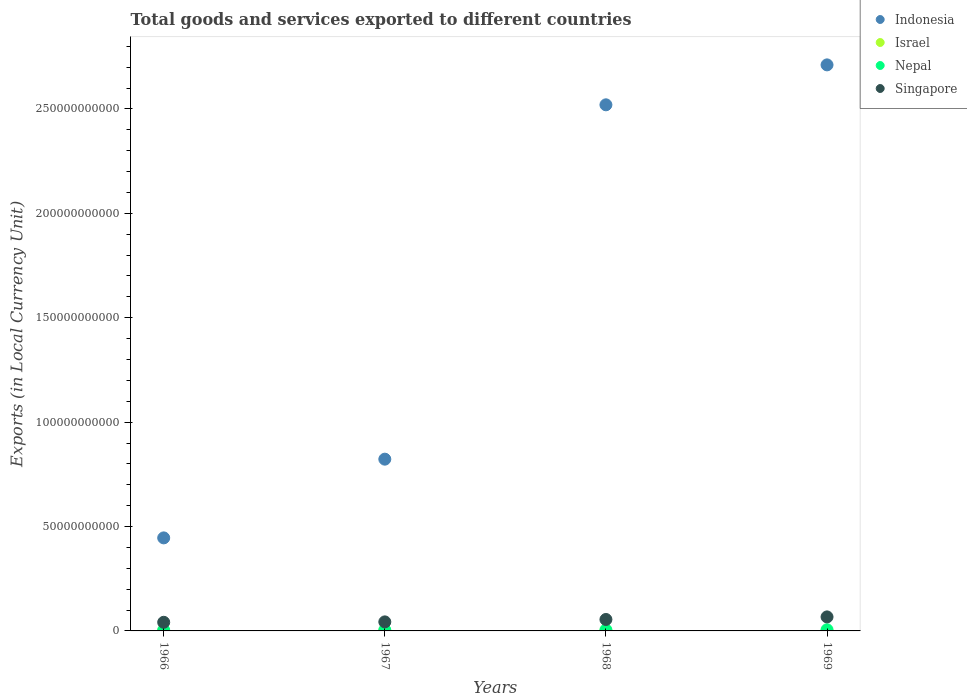What is the Amount of goods and services exports in Israel in 1967?
Ensure brevity in your answer.  2.86e+05. Across all years, what is the maximum Amount of goods and services exports in Nepal?
Provide a short and direct response. 5.60e+08. Across all years, what is the minimum Amount of goods and services exports in Nepal?
Your answer should be compact. 3.90e+08. In which year was the Amount of goods and services exports in Israel maximum?
Ensure brevity in your answer.  1969. In which year was the Amount of goods and services exports in Singapore minimum?
Your answer should be very brief. 1966. What is the total Amount of goods and services exports in Singapore in the graph?
Your response must be concise. 2.07e+1. What is the difference between the Amount of goods and services exports in Indonesia in 1966 and that in 1968?
Your answer should be compact. -2.07e+11. What is the difference between the Amount of goods and services exports in Indonesia in 1969 and the Amount of goods and services exports in Nepal in 1968?
Your answer should be compact. 2.71e+11. What is the average Amount of goods and services exports in Israel per year?
Provide a succinct answer. 3.51e+05. In the year 1968, what is the difference between the Amount of goods and services exports in Nepal and Amount of goods and services exports in Israel?
Your answer should be very brief. 4.91e+08. In how many years, is the Amount of goods and services exports in Israel greater than 220000000000 LCU?
Keep it short and to the point. 0. What is the ratio of the Amount of goods and services exports in Israel in 1968 to that in 1969?
Offer a terse response. 0.89. Is the Amount of goods and services exports in Israel in 1967 less than that in 1968?
Ensure brevity in your answer.  Yes. What is the difference between the highest and the second highest Amount of goods and services exports in Indonesia?
Provide a short and direct response. 1.91e+1. What is the difference between the highest and the lowest Amount of goods and services exports in Singapore?
Make the answer very short. 2.58e+09. In how many years, is the Amount of goods and services exports in Singapore greater than the average Amount of goods and services exports in Singapore taken over all years?
Your response must be concise. 2. Is it the case that in every year, the sum of the Amount of goods and services exports in Singapore and Amount of goods and services exports in Israel  is greater than the Amount of goods and services exports in Nepal?
Make the answer very short. Yes. Does the Amount of goods and services exports in Indonesia monotonically increase over the years?
Offer a very short reply. Yes. Is the Amount of goods and services exports in Indonesia strictly less than the Amount of goods and services exports in Nepal over the years?
Keep it short and to the point. No. Are the values on the major ticks of Y-axis written in scientific E-notation?
Your answer should be compact. No. Does the graph contain any zero values?
Your answer should be compact. No. Does the graph contain grids?
Your answer should be compact. No. Where does the legend appear in the graph?
Provide a short and direct response. Top right. How many legend labels are there?
Offer a very short reply. 4. How are the legend labels stacked?
Offer a terse response. Vertical. What is the title of the graph?
Your answer should be compact. Total goods and services exported to different countries. Does "Latin America(all income levels)" appear as one of the legend labels in the graph?
Ensure brevity in your answer.  No. What is the label or title of the Y-axis?
Ensure brevity in your answer.  Exports (in Local Currency Unit). What is the Exports (in Local Currency Unit) in Indonesia in 1966?
Your answer should be compact. 4.46e+1. What is the Exports (in Local Currency Unit) in Israel in 1966?
Offer a very short reply. 2.38e+05. What is the Exports (in Local Currency Unit) in Nepal in 1966?
Give a very brief answer. 3.90e+08. What is the Exports (in Local Currency Unit) in Singapore in 1966?
Provide a short and direct response. 4.14e+09. What is the Exports (in Local Currency Unit) of Indonesia in 1967?
Give a very brief answer. 8.23e+1. What is the Exports (in Local Currency Unit) in Israel in 1967?
Offer a terse response. 2.86e+05. What is the Exports (in Local Currency Unit) of Nepal in 1967?
Ensure brevity in your answer.  4.41e+08. What is the Exports (in Local Currency Unit) in Singapore in 1967?
Offer a very short reply. 4.33e+09. What is the Exports (in Local Currency Unit) in Indonesia in 1968?
Ensure brevity in your answer.  2.52e+11. What is the Exports (in Local Currency Unit) in Israel in 1968?
Provide a succinct answer. 4.13e+05. What is the Exports (in Local Currency Unit) of Nepal in 1968?
Your answer should be compact. 4.91e+08. What is the Exports (in Local Currency Unit) in Singapore in 1968?
Make the answer very short. 5.48e+09. What is the Exports (in Local Currency Unit) of Indonesia in 1969?
Your answer should be very brief. 2.71e+11. What is the Exports (in Local Currency Unit) of Israel in 1969?
Give a very brief answer. 4.66e+05. What is the Exports (in Local Currency Unit) of Nepal in 1969?
Give a very brief answer. 5.60e+08. What is the Exports (in Local Currency Unit) of Singapore in 1969?
Offer a very short reply. 6.71e+09. Across all years, what is the maximum Exports (in Local Currency Unit) in Indonesia?
Ensure brevity in your answer.  2.71e+11. Across all years, what is the maximum Exports (in Local Currency Unit) in Israel?
Your answer should be very brief. 4.66e+05. Across all years, what is the maximum Exports (in Local Currency Unit) in Nepal?
Make the answer very short. 5.60e+08. Across all years, what is the maximum Exports (in Local Currency Unit) in Singapore?
Provide a succinct answer. 6.71e+09. Across all years, what is the minimum Exports (in Local Currency Unit) of Indonesia?
Keep it short and to the point. 4.46e+1. Across all years, what is the minimum Exports (in Local Currency Unit) in Israel?
Your answer should be compact. 2.38e+05. Across all years, what is the minimum Exports (in Local Currency Unit) of Nepal?
Give a very brief answer. 3.90e+08. Across all years, what is the minimum Exports (in Local Currency Unit) of Singapore?
Your response must be concise. 4.14e+09. What is the total Exports (in Local Currency Unit) in Indonesia in the graph?
Ensure brevity in your answer.  6.50e+11. What is the total Exports (in Local Currency Unit) of Israel in the graph?
Your answer should be compact. 1.40e+06. What is the total Exports (in Local Currency Unit) of Nepal in the graph?
Provide a short and direct response. 1.88e+09. What is the total Exports (in Local Currency Unit) of Singapore in the graph?
Give a very brief answer. 2.07e+1. What is the difference between the Exports (in Local Currency Unit) in Indonesia in 1966 and that in 1967?
Give a very brief answer. -3.77e+1. What is the difference between the Exports (in Local Currency Unit) in Israel in 1966 and that in 1967?
Provide a short and direct response. -4.83e+04. What is the difference between the Exports (in Local Currency Unit) of Nepal in 1966 and that in 1967?
Give a very brief answer. -5.10e+07. What is the difference between the Exports (in Local Currency Unit) of Singapore in 1966 and that in 1967?
Offer a terse response. -1.94e+08. What is the difference between the Exports (in Local Currency Unit) in Indonesia in 1966 and that in 1968?
Provide a succinct answer. -2.07e+11. What is the difference between the Exports (in Local Currency Unit) in Israel in 1966 and that in 1968?
Offer a terse response. -1.75e+05. What is the difference between the Exports (in Local Currency Unit) in Nepal in 1966 and that in 1968?
Your response must be concise. -1.01e+08. What is the difference between the Exports (in Local Currency Unit) in Singapore in 1966 and that in 1968?
Your answer should be very brief. -1.35e+09. What is the difference between the Exports (in Local Currency Unit) of Indonesia in 1966 and that in 1969?
Offer a terse response. -2.27e+11. What is the difference between the Exports (in Local Currency Unit) in Israel in 1966 and that in 1969?
Ensure brevity in your answer.  -2.28e+05. What is the difference between the Exports (in Local Currency Unit) in Nepal in 1966 and that in 1969?
Offer a terse response. -1.70e+08. What is the difference between the Exports (in Local Currency Unit) in Singapore in 1966 and that in 1969?
Keep it short and to the point. -2.58e+09. What is the difference between the Exports (in Local Currency Unit) in Indonesia in 1967 and that in 1968?
Your answer should be compact. -1.70e+11. What is the difference between the Exports (in Local Currency Unit) of Israel in 1967 and that in 1968?
Your answer should be compact. -1.27e+05. What is the difference between the Exports (in Local Currency Unit) of Nepal in 1967 and that in 1968?
Ensure brevity in your answer.  -5.00e+07. What is the difference between the Exports (in Local Currency Unit) of Singapore in 1967 and that in 1968?
Keep it short and to the point. -1.15e+09. What is the difference between the Exports (in Local Currency Unit) of Indonesia in 1967 and that in 1969?
Provide a succinct answer. -1.89e+11. What is the difference between the Exports (in Local Currency Unit) in Israel in 1967 and that in 1969?
Make the answer very short. -1.80e+05. What is the difference between the Exports (in Local Currency Unit) in Nepal in 1967 and that in 1969?
Offer a terse response. -1.19e+08. What is the difference between the Exports (in Local Currency Unit) in Singapore in 1967 and that in 1969?
Keep it short and to the point. -2.38e+09. What is the difference between the Exports (in Local Currency Unit) of Indonesia in 1968 and that in 1969?
Your answer should be compact. -1.91e+1. What is the difference between the Exports (in Local Currency Unit) in Israel in 1968 and that in 1969?
Keep it short and to the point. -5.32e+04. What is the difference between the Exports (in Local Currency Unit) in Nepal in 1968 and that in 1969?
Make the answer very short. -6.90e+07. What is the difference between the Exports (in Local Currency Unit) in Singapore in 1968 and that in 1969?
Provide a succinct answer. -1.23e+09. What is the difference between the Exports (in Local Currency Unit) in Indonesia in 1966 and the Exports (in Local Currency Unit) in Israel in 1967?
Give a very brief answer. 4.46e+1. What is the difference between the Exports (in Local Currency Unit) in Indonesia in 1966 and the Exports (in Local Currency Unit) in Nepal in 1967?
Provide a short and direct response. 4.41e+1. What is the difference between the Exports (in Local Currency Unit) in Indonesia in 1966 and the Exports (in Local Currency Unit) in Singapore in 1967?
Provide a succinct answer. 4.02e+1. What is the difference between the Exports (in Local Currency Unit) of Israel in 1966 and the Exports (in Local Currency Unit) of Nepal in 1967?
Keep it short and to the point. -4.41e+08. What is the difference between the Exports (in Local Currency Unit) in Israel in 1966 and the Exports (in Local Currency Unit) in Singapore in 1967?
Make the answer very short. -4.33e+09. What is the difference between the Exports (in Local Currency Unit) of Nepal in 1966 and the Exports (in Local Currency Unit) of Singapore in 1967?
Provide a short and direct response. -3.94e+09. What is the difference between the Exports (in Local Currency Unit) of Indonesia in 1966 and the Exports (in Local Currency Unit) of Israel in 1968?
Give a very brief answer. 4.46e+1. What is the difference between the Exports (in Local Currency Unit) in Indonesia in 1966 and the Exports (in Local Currency Unit) in Nepal in 1968?
Give a very brief answer. 4.41e+1. What is the difference between the Exports (in Local Currency Unit) in Indonesia in 1966 and the Exports (in Local Currency Unit) in Singapore in 1968?
Provide a short and direct response. 3.91e+1. What is the difference between the Exports (in Local Currency Unit) in Israel in 1966 and the Exports (in Local Currency Unit) in Nepal in 1968?
Keep it short and to the point. -4.91e+08. What is the difference between the Exports (in Local Currency Unit) in Israel in 1966 and the Exports (in Local Currency Unit) in Singapore in 1968?
Your answer should be compact. -5.48e+09. What is the difference between the Exports (in Local Currency Unit) of Nepal in 1966 and the Exports (in Local Currency Unit) of Singapore in 1968?
Your answer should be very brief. -5.09e+09. What is the difference between the Exports (in Local Currency Unit) in Indonesia in 1966 and the Exports (in Local Currency Unit) in Israel in 1969?
Provide a short and direct response. 4.46e+1. What is the difference between the Exports (in Local Currency Unit) of Indonesia in 1966 and the Exports (in Local Currency Unit) of Nepal in 1969?
Your answer should be compact. 4.40e+1. What is the difference between the Exports (in Local Currency Unit) in Indonesia in 1966 and the Exports (in Local Currency Unit) in Singapore in 1969?
Your answer should be very brief. 3.78e+1. What is the difference between the Exports (in Local Currency Unit) of Israel in 1966 and the Exports (in Local Currency Unit) of Nepal in 1969?
Give a very brief answer. -5.60e+08. What is the difference between the Exports (in Local Currency Unit) of Israel in 1966 and the Exports (in Local Currency Unit) of Singapore in 1969?
Your answer should be very brief. -6.71e+09. What is the difference between the Exports (in Local Currency Unit) of Nepal in 1966 and the Exports (in Local Currency Unit) of Singapore in 1969?
Make the answer very short. -6.32e+09. What is the difference between the Exports (in Local Currency Unit) in Indonesia in 1967 and the Exports (in Local Currency Unit) in Israel in 1968?
Keep it short and to the point. 8.23e+1. What is the difference between the Exports (in Local Currency Unit) in Indonesia in 1967 and the Exports (in Local Currency Unit) in Nepal in 1968?
Make the answer very short. 8.18e+1. What is the difference between the Exports (in Local Currency Unit) of Indonesia in 1967 and the Exports (in Local Currency Unit) of Singapore in 1968?
Your answer should be very brief. 7.68e+1. What is the difference between the Exports (in Local Currency Unit) of Israel in 1967 and the Exports (in Local Currency Unit) of Nepal in 1968?
Make the answer very short. -4.91e+08. What is the difference between the Exports (in Local Currency Unit) of Israel in 1967 and the Exports (in Local Currency Unit) of Singapore in 1968?
Keep it short and to the point. -5.48e+09. What is the difference between the Exports (in Local Currency Unit) in Nepal in 1967 and the Exports (in Local Currency Unit) in Singapore in 1968?
Keep it short and to the point. -5.04e+09. What is the difference between the Exports (in Local Currency Unit) of Indonesia in 1967 and the Exports (in Local Currency Unit) of Israel in 1969?
Your response must be concise. 8.23e+1. What is the difference between the Exports (in Local Currency Unit) of Indonesia in 1967 and the Exports (in Local Currency Unit) of Nepal in 1969?
Keep it short and to the point. 8.17e+1. What is the difference between the Exports (in Local Currency Unit) in Indonesia in 1967 and the Exports (in Local Currency Unit) in Singapore in 1969?
Ensure brevity in your answer.  7.55e+1. What is the difference between the Exports (in Local Currency Unit) of Israel in 1967 and the Exports (in Local Currency Unit) of Nepal in 1969?
Provide a succinct answer. -5.60e+08. What is the difference between the Exports (in Local Currency Unit) of Israel in 1967 and the Exports (in Local Currency Unit) of Singapore in 1969?
Your response must be concise. -6.71e+09. What is the difference between the Exports (in Local Currency Unit) of Nepal in 1967 and the Exports (in Local Currency Unit) of Singapore in 1969?
Provide a short and direct response. -6.27e+09. What is the difference between the Exports (in Local Currency Unit) of Indonesia in 1968 and the Exports (in Local Currency Unit) of Israel in 1969?
Keep it short and to the point. 2.52e+11. What is the difference between the Exports (in Local Currency Unit) in Indonesia in 1968 and the Exports (in Local Currency Unit) in Nepal in 1969?
Your response must be concise. 2.51e+11. What is the difference between the Exports (in Local Currency Unit) of Indonesia in 1968 and the Exports (in Local Currency Unit) of Singapore in 1969?
Offer a very short reply. 2.45e+11. What is the difference between the Exports (in Local Currency Unit) in Israel in 1968 and the Exports (in Local Currency Unit) in Nepal in 1969?
Ensure brevity in your answer.  -5.60e+08. What is the difference between the Exports (in Local Currency Unit) of Israel in 1968 and the Exports (in Local Currency Unit) of Singapore in 1969?
Provide a succinct answer. -6.71e+09. What is the difference between the Exports (in Local Currency Unit) of Nepal in 1968 and the Exports (in Local Currency Unit) of Singapore in 1969?
Offer a terse response. -6.22e+09. What is the average Exports (in Local Currency Unit) of Indonesia per year?
Keep it short and to the point. 1.62e+11. What is the average Exports (in Local Currency Unit) in Israel per year?
Offer a terse response. 3.51e+05. What is the average Exports (in Local Currency Unit) in Nepal per year?
Your answer should be compact. 4.70e+08. What is the average Exports (in Local Currency Unit) of Singapore per year?
Provide a succinct answer. 5.17e+09. In the year 1966, what is the difference between the Exports (in Local Currency Unit) of Indonesia and Exports (in Local Currency Unit) of Israel?
Your answer should be very brief. 4.46e+1. In the year 1966, what is the difference between the Exports (in Local Currency Unit) in Indonesia and Exports (in Local Currency Unit) in Nepal?
Ensure brevity in your answer.  4.42e+1. In the year 1966, what is the difference between the Exports (in Local Currency Unit) in Indonesia and Exports (in Local Currency Unit) in Singapore?
Provide a short and direct response. 4.04e+1. In the year 1966, what is the difference between the Exports (in Local Currency Unit) in Israel and Exports (in Local Currency Unit) in Nepal?
Make the answer very short. -3.90e+08. In the year 1966, what is the difference between the Exports (in Local Currency Unit) in Israel and Exports (in Local Currency Unit) in Singapore?
Offer a terse response. -4.14e+09. In the year 1966, what is the difference between the Exports (in Local Currency Unit) of Nepal and Exports (in Local Currency Unit) of Singapore?
Provide a short and direct response. -3.75e+09. In the year 1967, what is the difference between the Exports (in Local Currency Unit) in Indonesia and Exports (in Local Currency Unit) in Israel?
Your response must be concise. 8.23e+1. In the year 1967, what is the difference between the Exports (in Local Currency Unit) in Indonesia and Exports (in Local Currency Unit) in Nepal?
Your answer should be compact. 8.18e+1. In the year 1967, what is the difference between the Exports (in Local Currency Unit) of Indonesia and Exports (in Local Currency Unit) of Singapore?
Your answer should be very brief. 7.79e+1. In the year 1967, what is the difference between the Exports (in Local Currency Unit) in Israel and Exports (in Local Currency Unit) in Nepal?
Provide a succinct answer. -4.41e+08. In the year 1967, what is the difference between the Exports (in Local Currency Unit) of Israel and Exports (in Local Currency Unit) of Singapore?
Your answer should be very brief. -4.33e+09. In the year 1967, what is the difference between the Exports (in Local Currency Unit) of Nepal and Exports (in Local Currency Unit) of Singapore?
Offer a very short reply. -3.89e+09. In the year 1968, what is the difference between the Exports (in Local Currency Unit) in Indonesia and Exports (in Local Currency Unit) in Israel?
Offer a very short reply. 2.52e+11. In the year 1968, what is the difference between the Exports (in Local Currency Unit) of Indonesia and Exports (in Local Currency Unit) of Nepal?
Provide a succinct answer. 2.51e+11. In the year 1968, what is the difference between the Exports (in Local Currency Unit) in Indonesia and Exports (in Local Currency Unit) in Singapore?
Provide a succinct answer. 2.46e+11. In the year 1968, what is the difference between the Exports (in Local Currency Unit) of Israel and Exports (in Local Currency Unit) of Nepal?
Your answer should be very brief. -4.91e+08. In the year 1968, what is the difference between the Exports (in Local Currency Unit) of Israel and Exports (in Local Currency Unit) of Singapore?
Ensure brevity in your answer.  -5.48e+09. In the year 1968, what is the difference between the Exports (in Local Currency Unit) of Nepal and Exports (in Local Currency Unit) of Singapore?
Make the answer very short. -4.99e+09. In the year 1969, what is the difference between the Exports (in Local Currency Unit) in Indonesia and Exports (in Local Currency Unit) in Israel?
Provide a succinct answer. 2.71e+11. In the year 1969, what is the difference between the Exports (in Local Currency Unit) of Indonesia and Exports (in Local Currency Unit) of Nepal?
Keep it short and to the point. 2.71e+11. In the year 1969, what is the difference between the Exports (in Local Currency Unit) of Indonesia and Exports (in Local Currency Unit) of Singapore?
Provide a short and direct response. 2.64e+11. In the year 1969, what is the difference between the Exports (in Local Currency Unit) of Israel and Exports (in Local Currency Unit) of Nepal?
Your response must be concise. -5.60e+08. In the year 1969, what is the difference between the Exports (in Local Currency Unit) of Israel and Exports (in Local Currency Unit) of Singapore?
Offer a very short reply. -6.71e+09. In the year 1969, what is the difference between the Exports (in Local Currency Unit) of Nepal and Exports (in Local Currency Unit) of Singapore?
Your response must be concise. -6.15e+09. What is the ratio of the Exports (in Local Currency Unit) of Indonesia in 1966 to that in 1967?
Your answer should be compact. 0.54. What is the ratio of the Exports (in Local Currency Unit) of Israel in 1966 to that in 1967?
Provide a succinct answer. 0.83. What is the ratio of the Exports (in Local Currency Unit) of Nepal in 1966 to that in 1967?
Ensure brevity in your answer.  0.88. What is the ratio of the Exports (in Local Currency Unit) of Singapore in 1966 to that in 1967?
Make the answer very short. 0.96. What is the ratio of the Exports (in Local Currency Unit) of Indonesia in 1966 to that in 1968?
Offer a very short reply. 0.18. What is the ratio of the Exports (in Local Currency Unit) in Israel in 1966 to that in 1968?
Your answer should be very brief. 0.58. What is the ratio of the Exports (in Local Currency Unit) in Nepal in 1966 to that in 1968?
Your answer should be very brief. 0.79. What is the ratio of the Exports (in Local Currency Unit) of Singapore in 1966 to that in 1968?
Your answer should be compact. 0.75. What is the ratio of the Exports (in Local Currency Unit) in Indonesia in 1966 to that in 1969?
Ensure brevity in your answer.  0.16. What is the ratio of the Exports (in Local Currency Unit) in Israel in 1966 to that in 1969?
Keep it short and to the point. 0.51. What is the ratio of the Exports (in Local Currency Unit) of Nepal in 1966 to that in 1969?
Your answer should be very brief. 0.7. What is the ratio of the Exports (in Local Currency Unit) of Singapore in 1966 to that in 1969?
Make the answer very short. 0.62. What is the ratio of the Exports (in Local Currency Unit) in Indonesia in 1967 to that in 1968?
Offer a very short reply. 0.33. What is the ratio of the Exports (in Local Currency Unit) of Israel in 1967 to that in 1968?
Offer a terse response. 0.69. What is the ratio of the Exports (in Local Currency Unit) of Nepal in 1967 to that in 1968?
Your answer should be very brief. 0.9. What is the ratio of the Exports (in Local Currency Unit) in Singapore in 1967 to that in 1968?
Give a very brief answer. 0.79. What is the ratio of the Exports (in Local Currency Unit) of Indonesia in 1967 to that in 1969?
Offer a very short reply. 0.3. What is the ratio of the Exports (in Local Currency Unit) of Israel in 1967 to that in 1969?
Make the answer very short. 0.61. What is the ratio of the Exports (in Local Currency Unit) of Nepal in 1967 to that in 1969?
Offer a terse response. 0.79. What is the ratio of the Exports (in Local Currency Unit) of Singapore in 1967 to that in 1969?
Your answer should be very brief. 0.65. What is the ratio of the Exports (in Local Currency Unit) in Indonesia in 1968 to that in 1969?
Provide a short and direct response. 0.93. What is the ratio of the Exports (in Local Currency Unit) of Israel in 1968 to that in 1969?
Provide a short and direct response. 0.89. What is the ratio of the Exports (in Local Currency Unit) of Nepal in 1968 to that in 1969?
Ensure brevity in your answer.  0.88. What is the ratio of the Exports (in Local Currency Unit) in Singapore in 1968 to that in 1969?
Make the answer very short. 0.82. What is the difference between the highest and the second highest Exports (in Local Currency Unit) of Indonesia?
Offer a terse response. 1.91e+1. What is the difference between the highest and the second highest Exports (in Local Currency Unit) of Israel?
Your answer should be very brief. 5.32e+04. What is the difference between the highest and the second highest Exports (in Local Currency Unit) of Nepal?
Offer a terse response. 6.90e+07. What is the difference between the highest and the second highest Exports (in Local Currency Unit) of Singapore?
Your answer should be compact. 1.23e+09. What is the difference between the highest and the lowest Exports (in Local Currency Unit) of Indonesia?
Provide a short and direct response. 2.27e+11. What is the difference between the highest and the lowest Exports (in Local Currency Unit) in Israel?
Provide a short and direct response. 2.28e+05. What is the difference between the highest and the lowest Exports (in Local Currency Unit) of Nepal?
Your answer should be very brief. 1.70e+08. What is the difference between the highest and the lowest Exports (in Local Currency Unit) of Singapore?
Provide a short and direct response. 2.58e+09. 